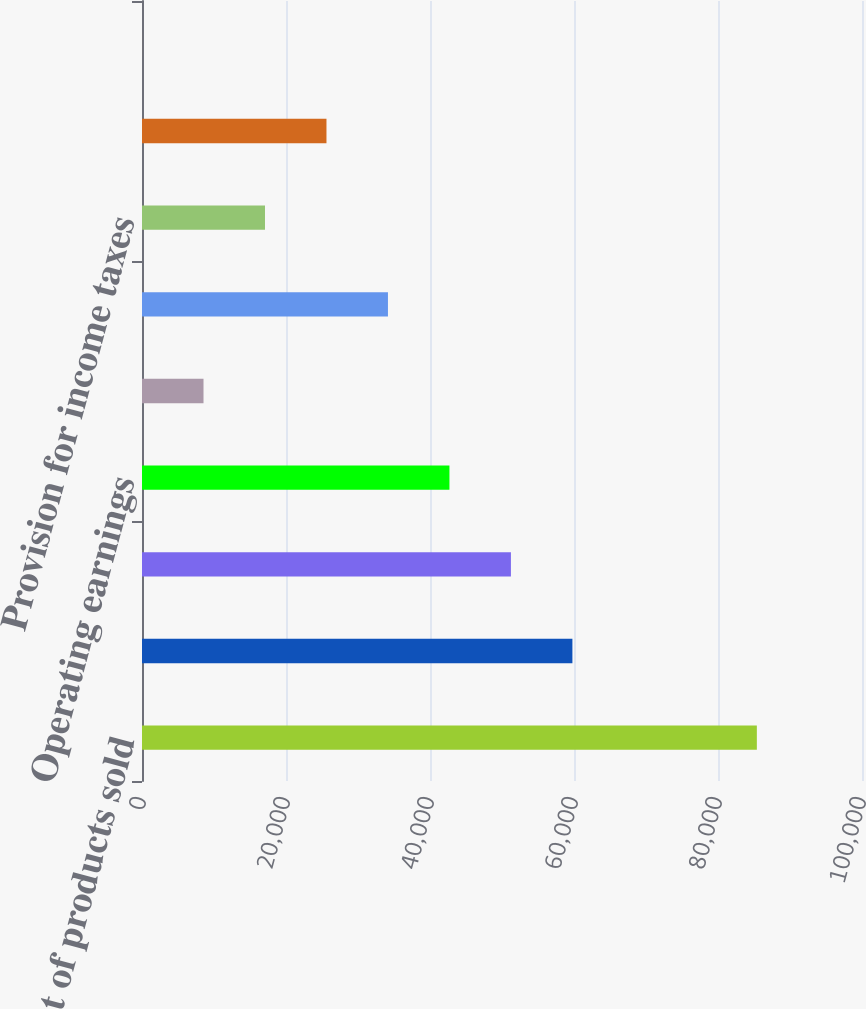Convert chart. <chart><loc_0><loc_0><loc_500><loc_500><bar_chart><fcel>Cost of products sold<fcel>Gross margin<fcel>Selling general and<fcel>Operating earnings<fcel>Interest expense and other<fcel>Earnings before income taxes<fcel>Provision for income taxes<fcel>Earnings from continuing<fcel>Net diluted earnings per<nl><fcel>85395.8<fcel>59778.1<fcel>51238.9<fcel>42699.7<fcel>8542.79<fcel>34160.4<fcel>17082<fcel>25621.2<fcel>3.57<nl></chart> 